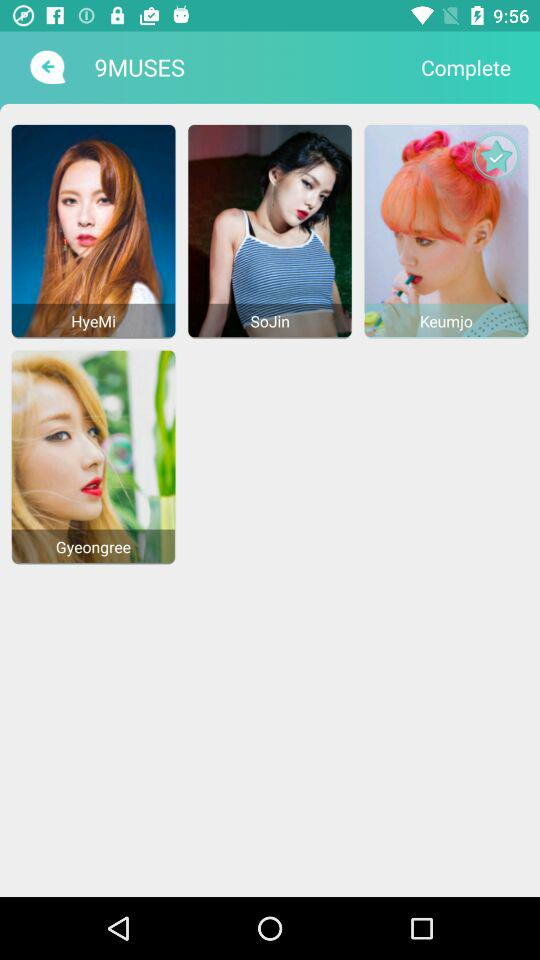What is the application name? The application name is "9MUSES". 